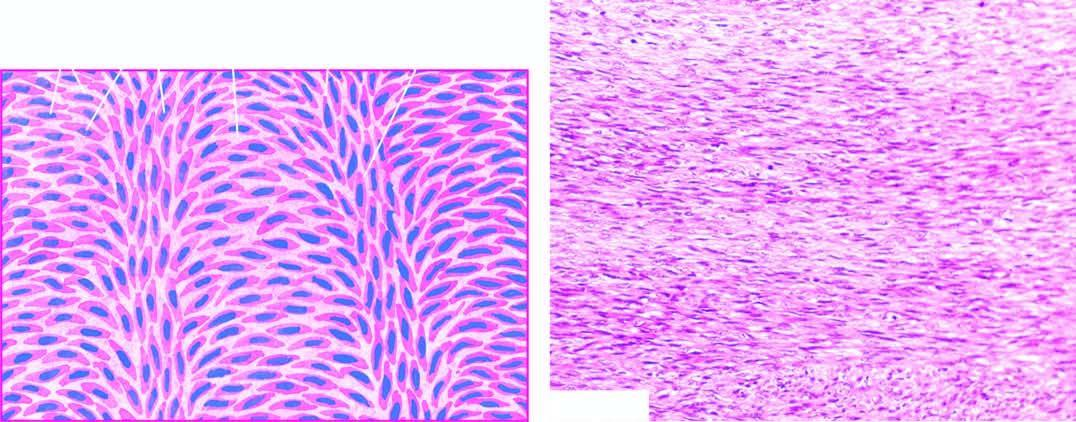what are also seen?
Answer the question using a single word or phrase. A few mitotic figures 